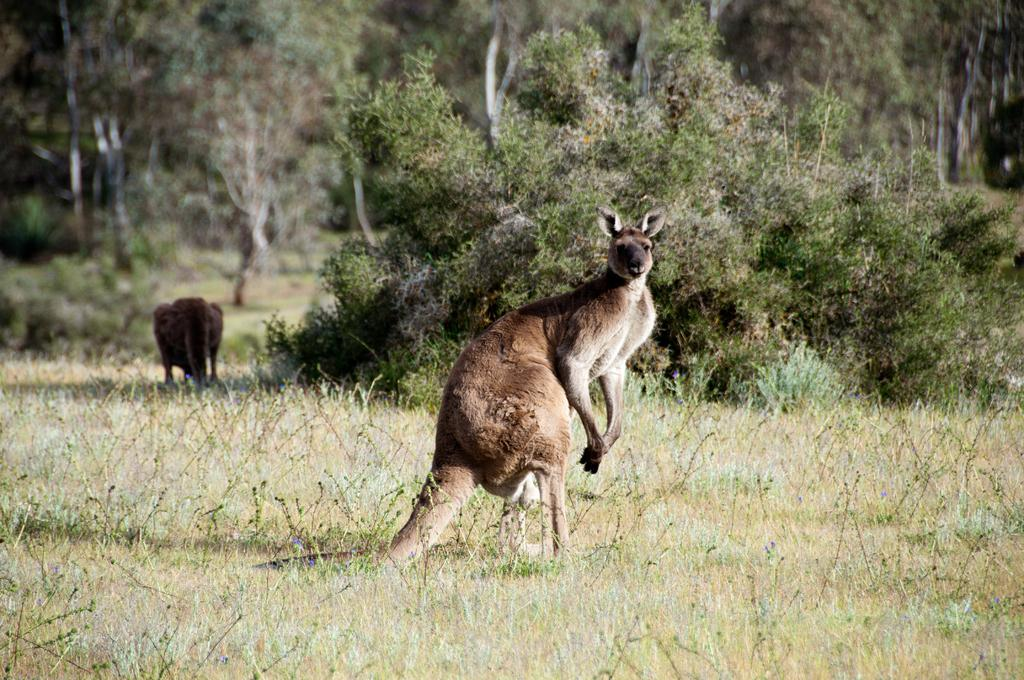What animals are present in the image? There are kangaroos in the image. Where are the kangaroos located? The kangaroos are on the grass. What can be seen in the background of the image? There are plants and trees in the background of the image. What type of curtain can be seen hanging in the image? There is no curtain present in the image, as it features kangaroos on the grass with plants and trees in the background. 